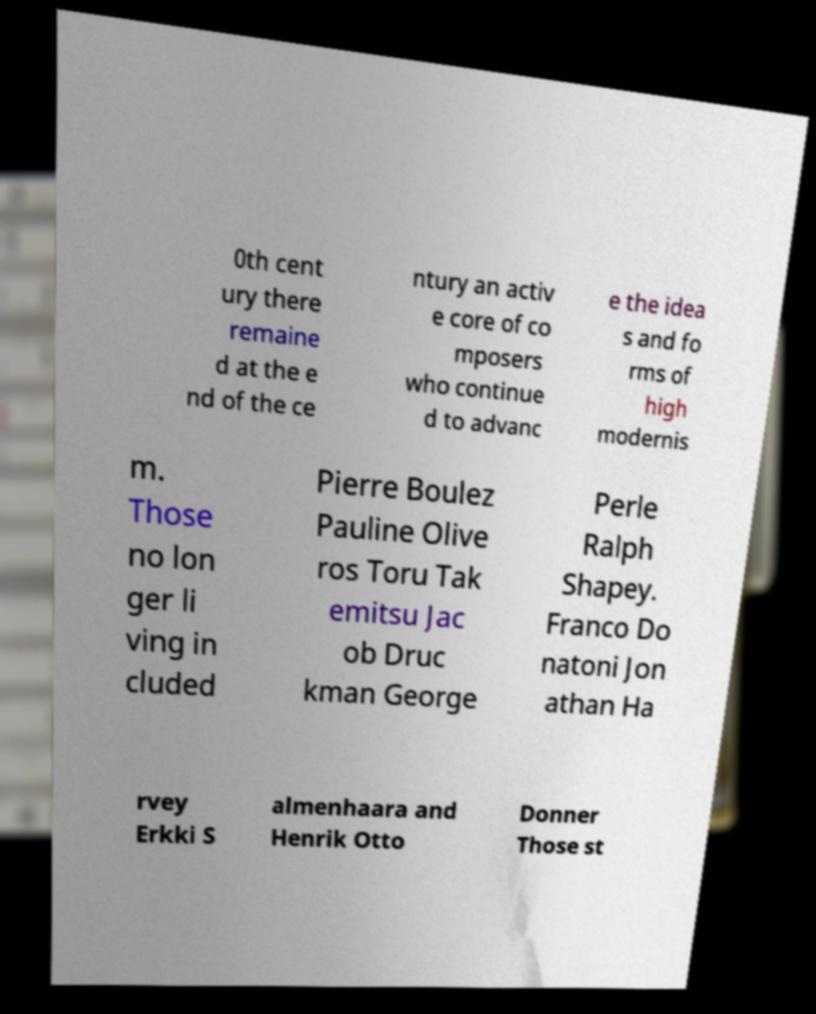Can you read and provide the text displayed in the image?This photo seems to have some interesting text. Can you extract and type it out for me? 0th cent ury there remaine d at the e nd of the ce ntury an activ e core of co mposers who continue d to advanc e the idea s and fo rms of high modernis m. Those no lon ger li ving in cluded Pierre Boulez Pauline Olive ros Toru Tak emitsu Jac ob Druc kman George Perle Ralph Shapey. Franco Do natoni Jon athan Ha rvey Erkki S almenhaara and Henrik Otto Donner Those st 